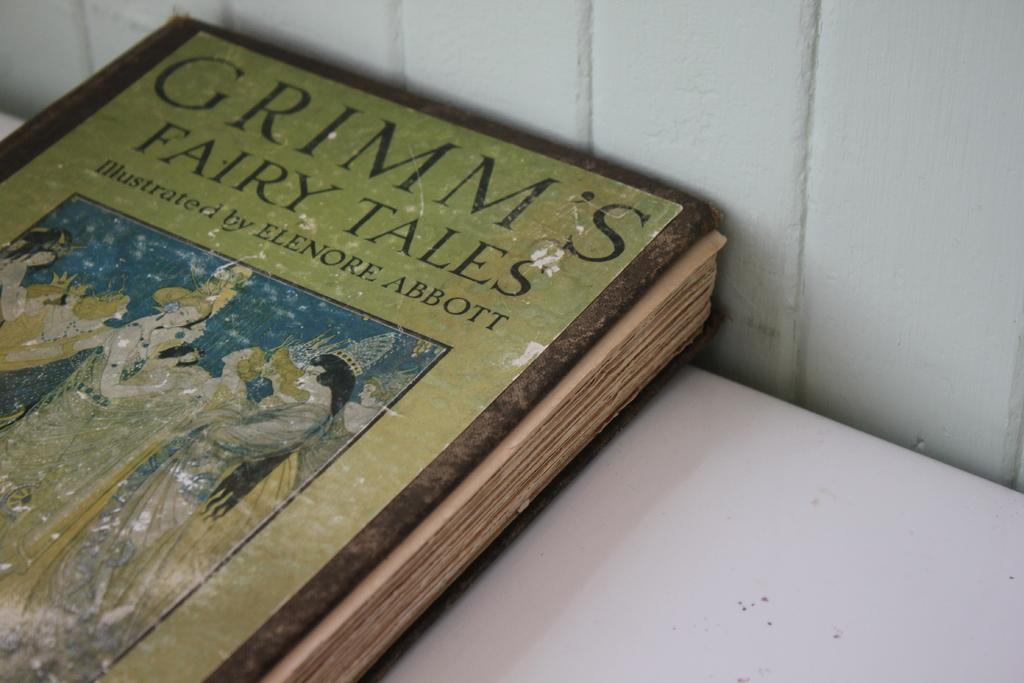<image>
Present a compact description of the photo's key features. a book that is titled 'grimm's fairy tales' 'illustrated by elenore abbott 